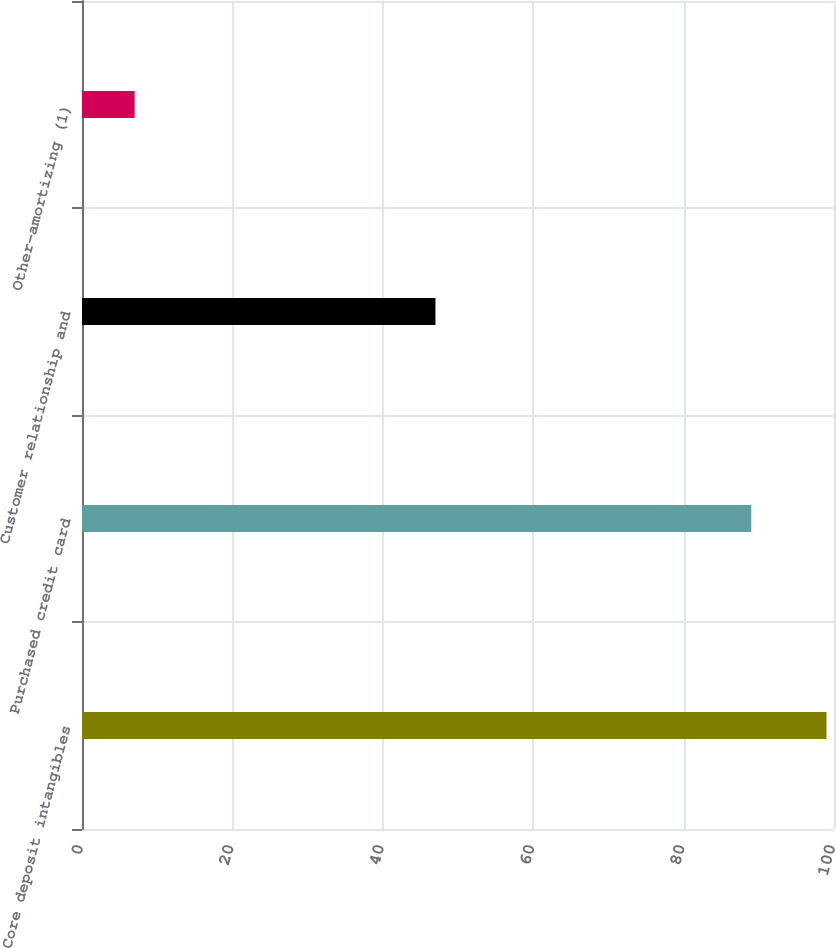Convert chart. <chart><loc_0><loc_0><loc_500><loc_500><bar_chart><fcel>Core deposit intangibles<fcel>Purchased credit card<fcel>Customer relationship and<fcel>Other-amortizing (1)<nl><fcel>99<fcel>89<fcel>47<fcel>7<nl></chart> 